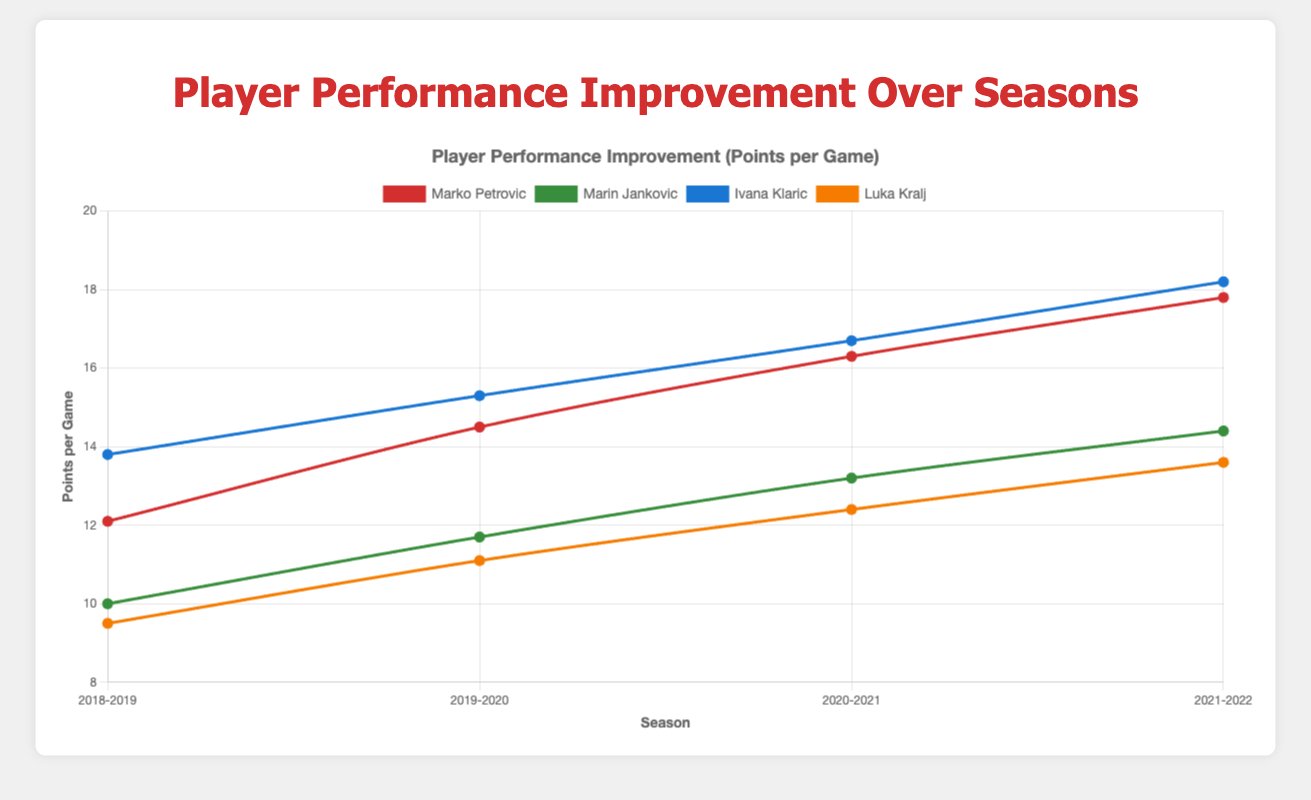Which player had the highest points per game in the 2021-2022 season? Look at the data for the 2021-2022 season and compare the points per game for each player. Ivana Klaric had 18.2 points per game.
Answer: Ivana Klaric Whose improvement in points per game was the greatest from 2018-2019 to 2021-2022? Calculate the difference in points per game between the 2021-2022 and 2018-2019 seasons for each player. Compare these differences.
Answer: Ivana Klaric How did Marko Petrovic's points per game change between the 2019-2020 and 2020-2021 seasons? Look at Marko Petrovic's points per game for the 2019-2020 (14.5) and 2020-2021 (16.3) seasons. Compute the difference: 16.3 - 14.5.
Answer: Increased by 1.8 Between Marin Jankovic and Luka Kralj, who had a more consistent performance in terms of points per game across the four seasons? Compare the variation (how much the points per game fluctuated) for both players over the four seasons. Consistency can be assessed by noting smaller variations.
Answer: Luka Kralj What is the average points per game for Ivana Klaric over the four seasons? Sum Ivana Klaric's points per game for all seasons (13.8 + 15.3 + 16.7 + 18.2) and divide by 4. (64 / 4).
Answer: 16.0 Compare the points per game improvement for Marko Petrovic and Marin Jankovic from 2018-2019 to 2021-2022. Who showed greater improvement? Calculate the difference in points per game for each player from 2018-2019 to 2021-2022. Marko Petrovic: 17.8 - 12.1 = 5.7, Marin Jankovic: 14.4 - 10.0 = 4.4.
Answer: Marko Petrovic Which player had the lowest points per game in the 2018-2019 season? Compare the points per game for each player in the 2018-2019 season. Luka Kralj had 9.5 points per game.
Answer: Luka Kralj 